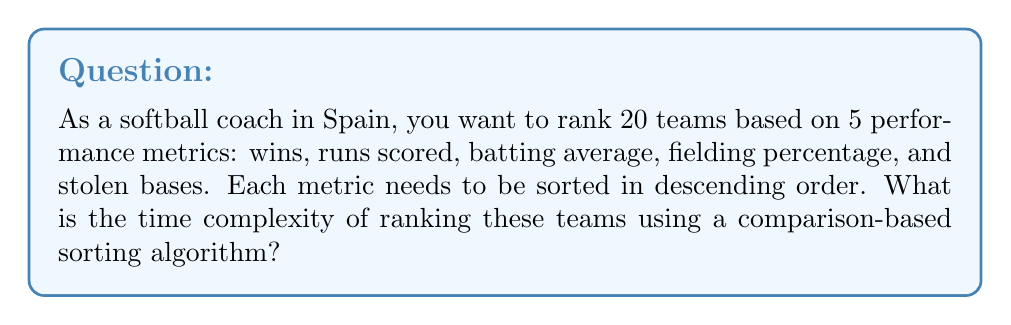Provide a solution to this math problem. To solve this problem, we need to consider the following steps:

1. We have $n = 20$ teams and $m = 5$ metrics.

2. For each metric, we need to sort the teams. The best comparison-based sorting algorithms (e.g., Merge Sort, Heap Sort) have a time complexity of $O(n \log n)$ for a single sort.

3. We need to perform this sorting for each of the $m$ metrics.

4. The total time complexity will be the product of the number of metrics and the time complexity of a single sort.

Therefore, the time complexity can be calculated as:

$$O(m \cdot n \log n)$$

Substituting the values:

$$O(5 \cdot 20 \log 20)$$

This can be simplified to:

$$O(100 \log 20)$$

However, in Big O notation, we typically express the complexity in terms of variables, not specific values. So, the final time complexity remains:

$$O(m \cdot n \log n)$$

Where $n$ is the number of teams and $m$ is the number of metrics.

This complexity reflects that for each of the $m$ metrics, we're performing a sort that takes $O(n \log n)$ time.
Answer: $O(m \cdot n \log n)$, where $n$ is the number of teams and $m$ is the number of metrics. 